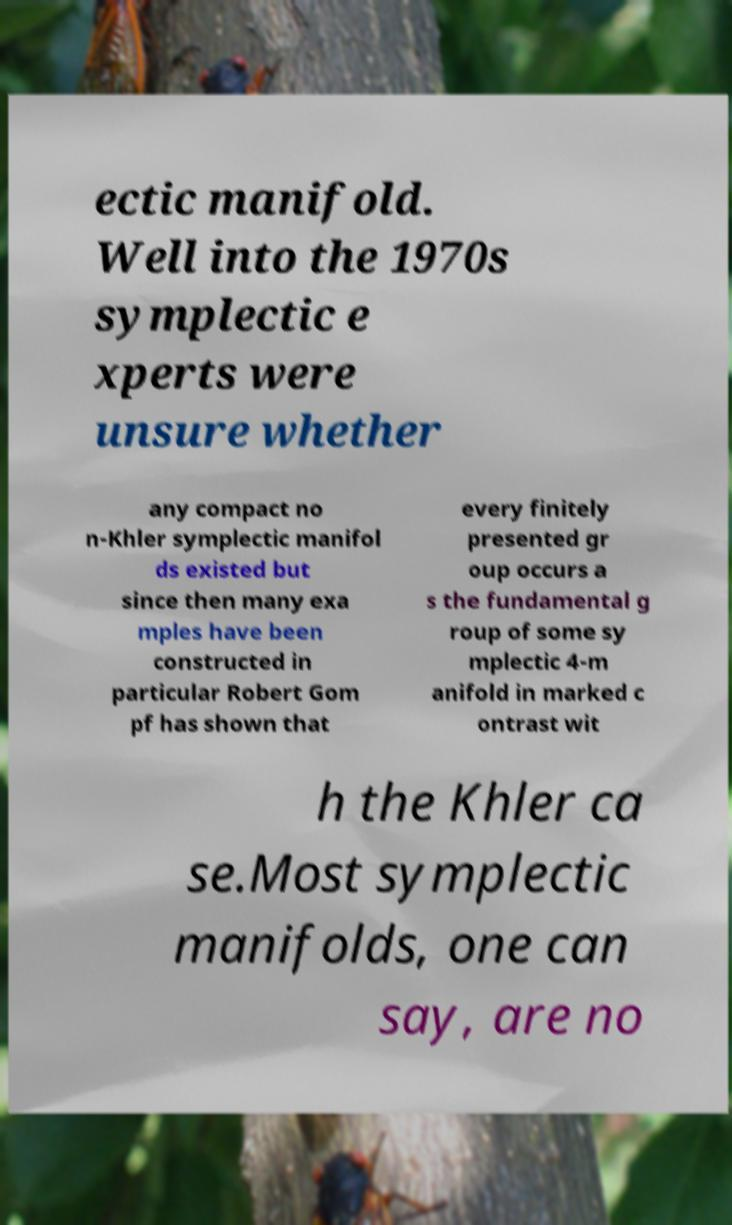Can you read and provide the text displayed in the image?This photo seems to have some interesting text. Can you extract and type it out for me? ectic manifold. Well into the 1970s symplectic e xperts were unsure whether any compact no n-Khler symplectic manifol ds existed but since then many exa mples have been constructed in particular Robert Gom pf has shown that every finitely presented gr oup occurs a s the fundamental g roup of some sy mplectic 4-m anifold in marked c ontrast wit h the Khler ca se.Most symplectic manifolds, one can say, are no 